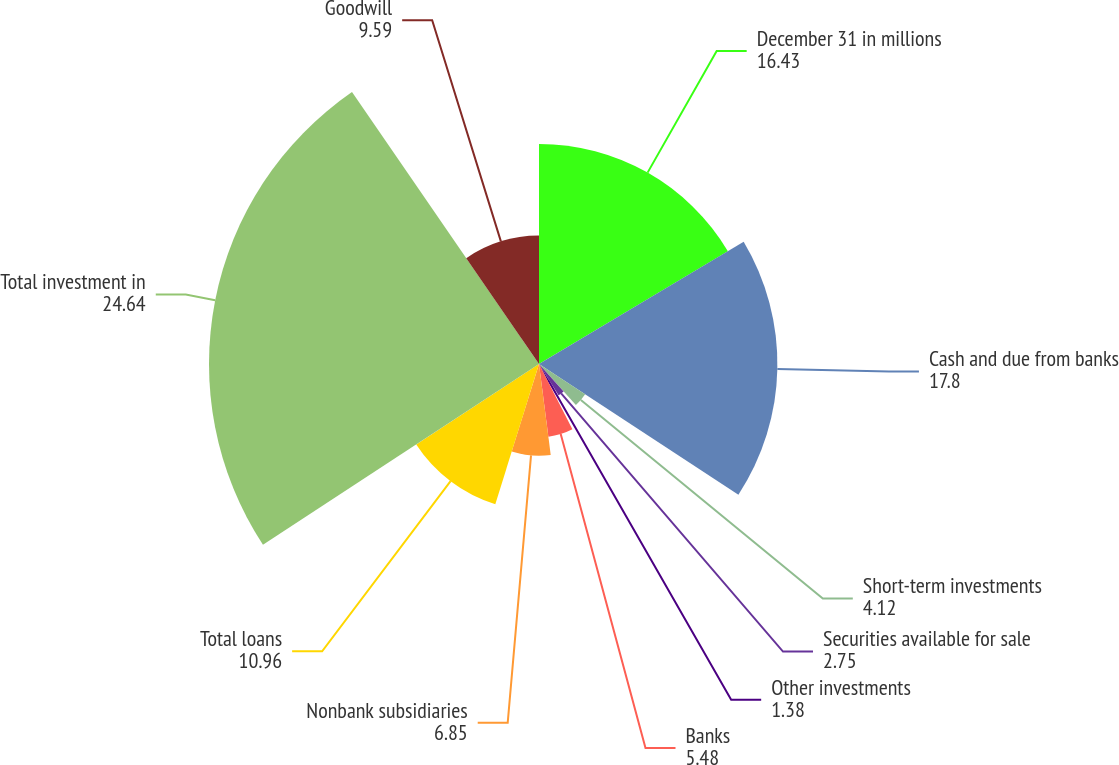Convert chart. <chart><loc_0><loc_0><loc_500><loc_500><pie_chart><fcel>December 31 in millions<fcel>Cash and due from banks<fcel>Short-term investments<fcel>Securities available for sale<fcel>Other investments<fcel>Banks<fcel>Nonbank subsidiaries<fcel>Total loans<fcel>Total investment in<fcel>Goodwill<nl><fcel>16.43%<fcel>17.8%<fcel>4.12%<fcel>2.75%<fcel>1.38%<fcel>5.48%<fcel>6.85%<fcel>10.96%<fcel>24.64%<fcel>9.59%<nl></chart> 